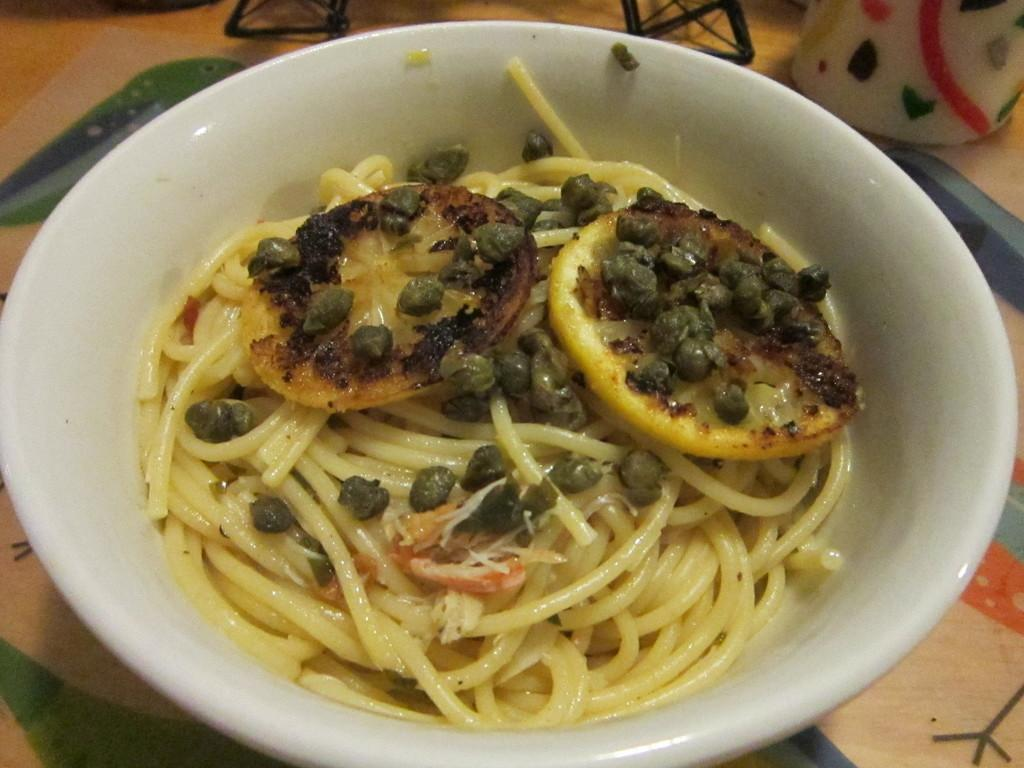What is present in the image? There is a bowl in the image. What color is the bowl? The bowl is white in color. What can be found inside the bowl? There are food items in the bowl. What time does the clock show in the image? There is no clock present in the image. What day of the week is it in the image? The day of the week cannot be determined from the image, as it only contains a bowl with food items. 